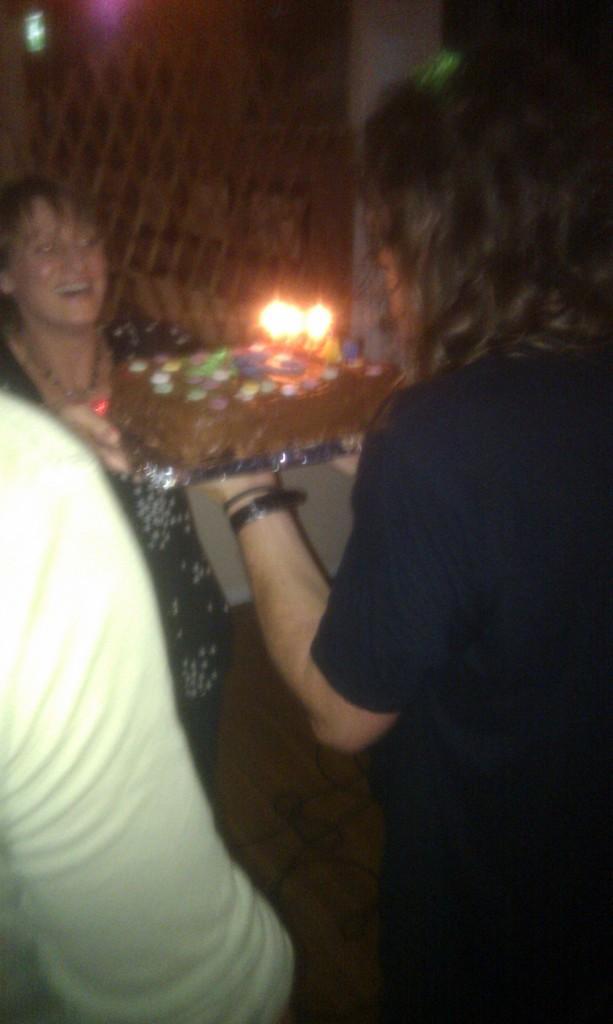Could you give a brief overview of what you see in this image? In the picture I can see people are standing. In the background I can see lights and some other objects. 